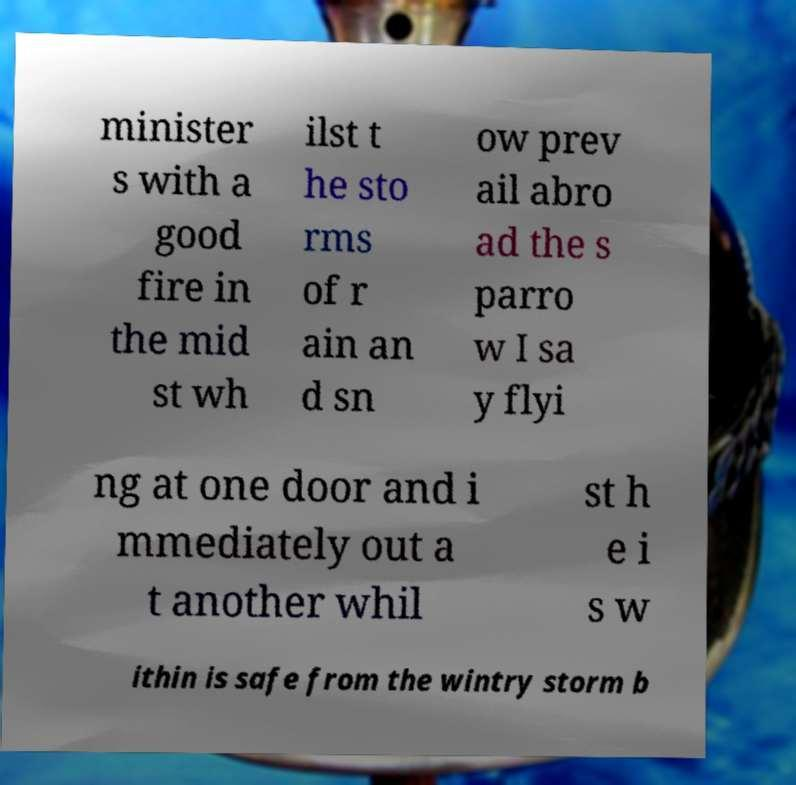Please read and relay the text visible in this image. What does it say? minister s with a good fire in the mid st wh ilst t he sto rms of r ain an d sn ow prev ail abro ad the s parro w I sa y flyi ng at one door and i mmediately out a t another whil st h e i s w ithin is safe from the wintry storm b 